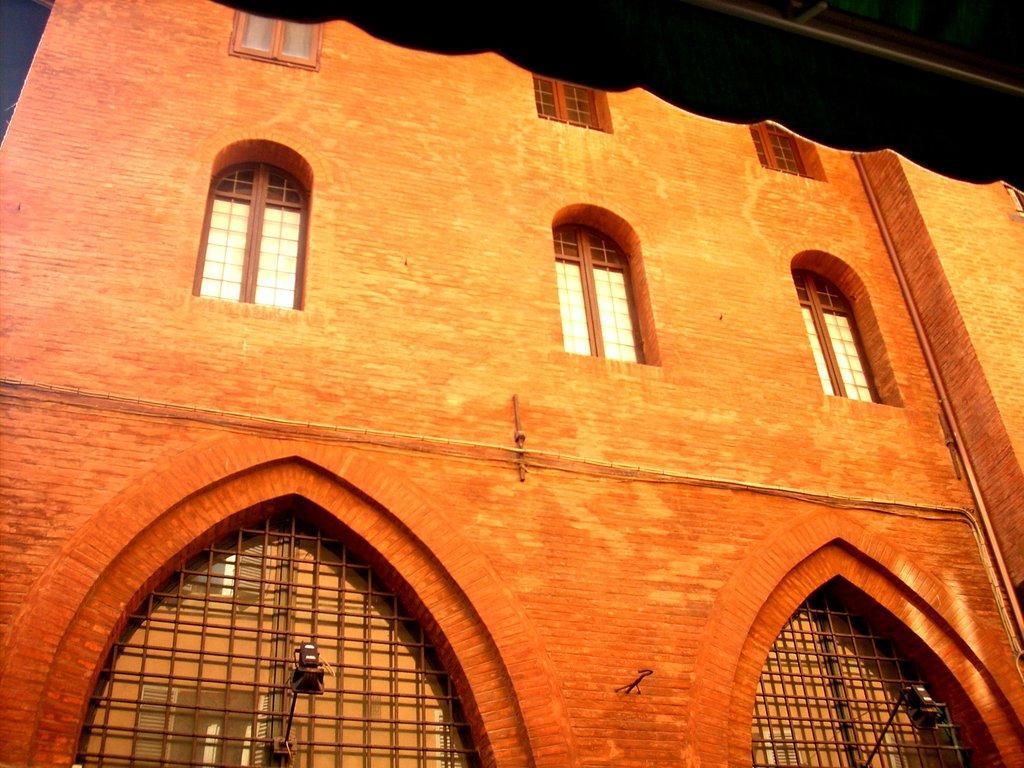In one or two sentences, can you explain what this image depicts? In this image we can see a building with glass windows, lights and other objects. On the right side top of the image there is an object. 